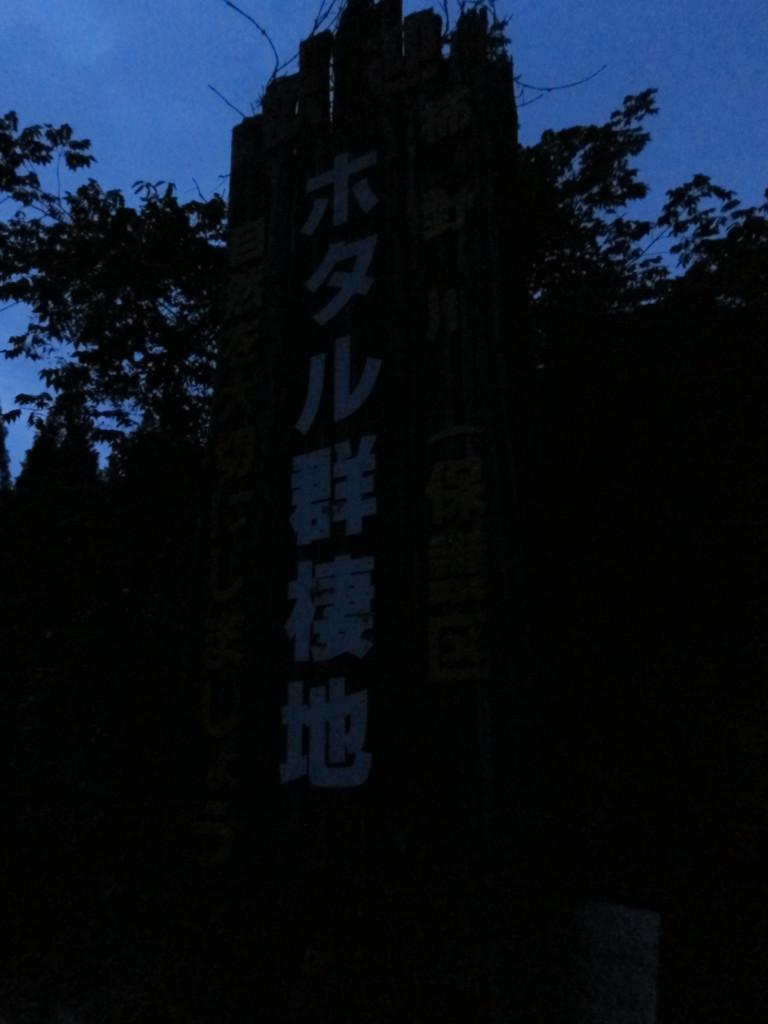How would you summarize this image in a sentence or two? At the top portion of the picture we can see a clear blue sky and trees. This picture is completely dark. 